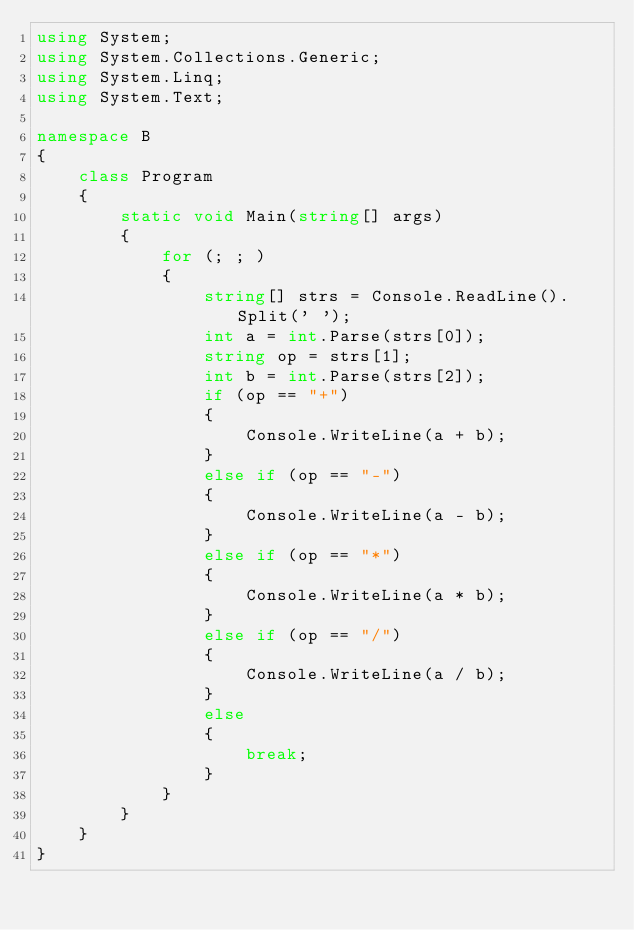<code> <loc_0><loc_0><loc_500><loc_500><_C#_>using System;
using System.Collections.Generic;
using System.Linq;
using System.Text;

namespace B
{
    class Program
    {
        static void Main(string[] args)
        {
            for (; ; )
            {
                string[] strs = Console.ReadLine().Split(' ');
                int a = int.Parse(strs[0]);
                string op = strs[1];
                int b = int.Parse(strs[2]);
                if (op == "+")
                {
                    Console.WriteLine(a + b);
                }
                else if (op == "-")
                {
                    Console.WriteLine(a - b);
                }
                else if (op == "*")
                {
                    Console.WriteLine(a * b);
                }
                else if (op == "/")
                {
                    Console.WriteLine(a / b);
                }
                else
                {
                    break;
                }
            }
        }
    }
}</code> 